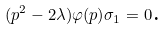<formula> <loc_0><loc_0><loc_500><loc_500>( p ^ { 2 } - 2 \lambda ) \varphi ( p ) \sigma _ { 1 } = 0 \text {. }</formula> 